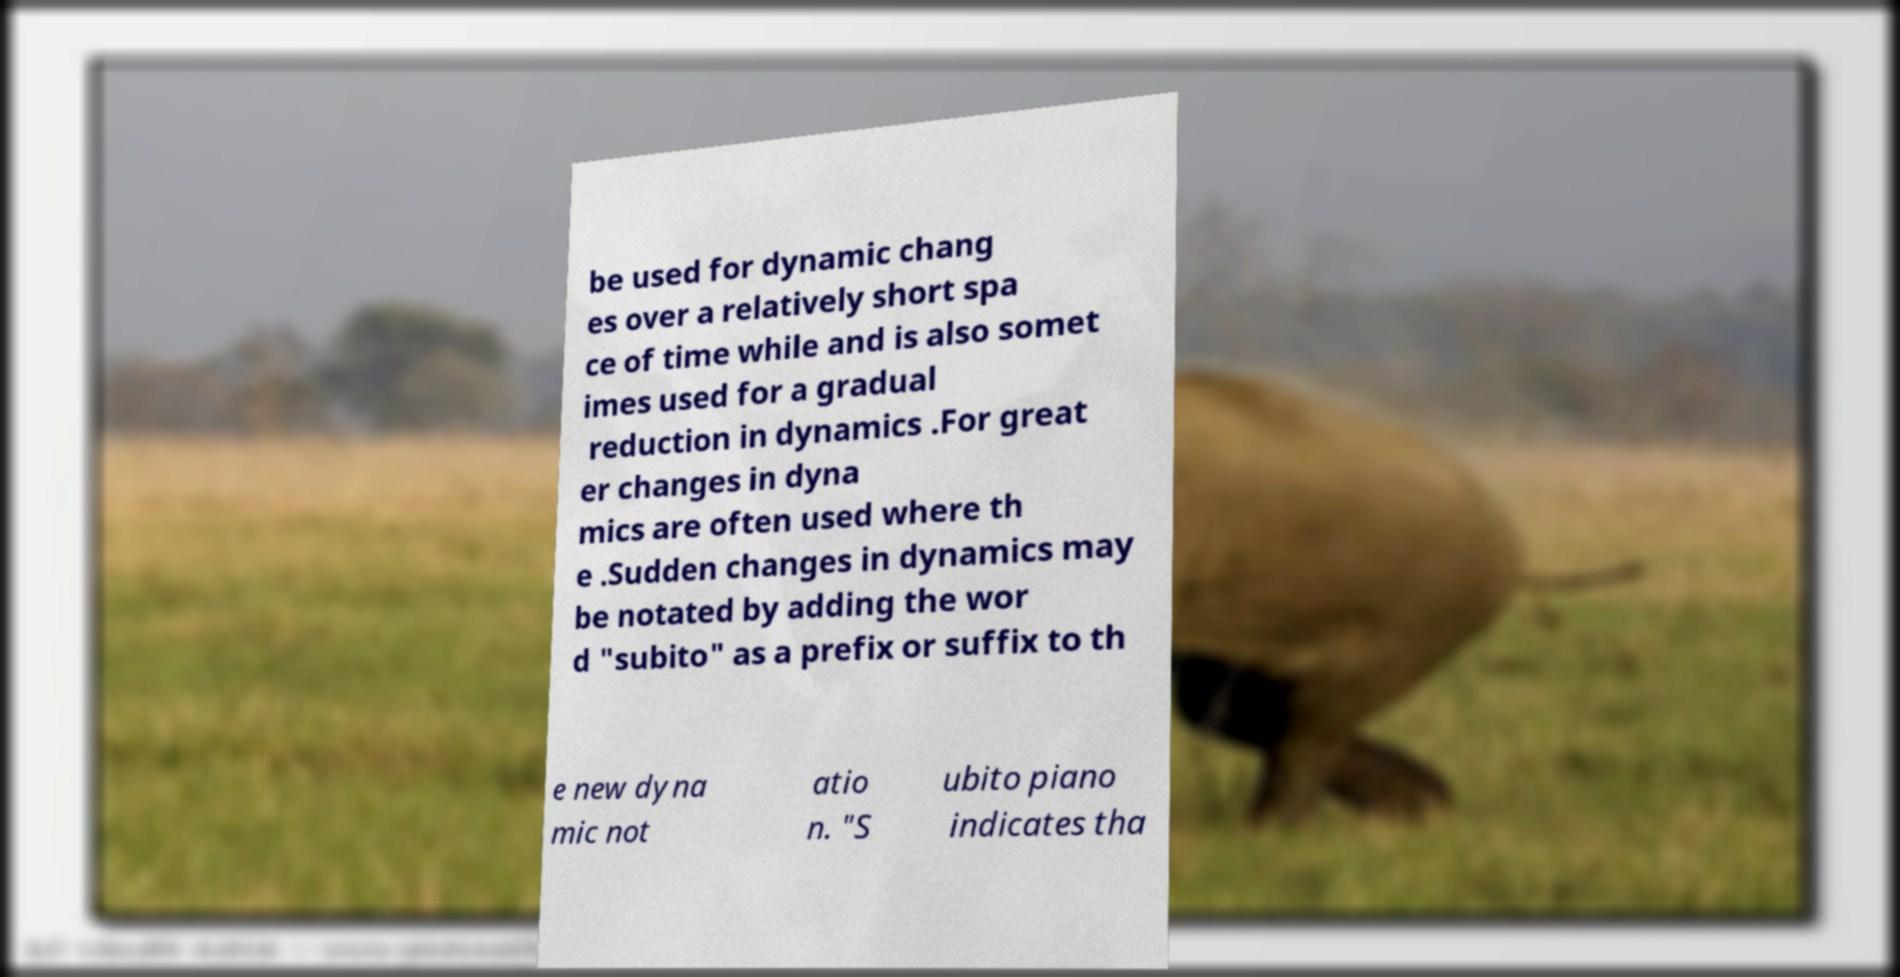Could you assist in decoding the text presented in this image and type it out clearly? be used for dynamic chang es over a relatively short spa ce of time while and is also somet imes used for a gradual reduction in dynamics .For great er changes in dyna mics are often used where th e .Sudden changes in dynamics may be notated by adding the wor d "subito" as a prefix or suffix to th e new dyna mic not atio n. "S ubito piano indicates tha 